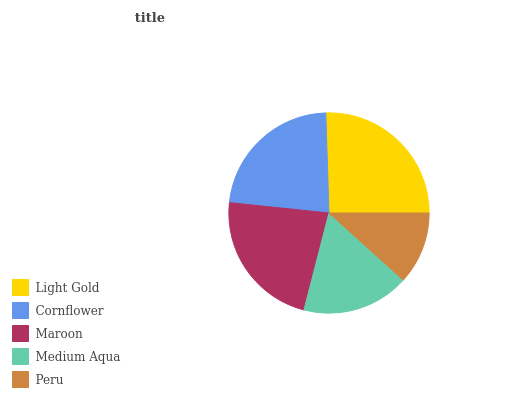Is Peru the minimum?
Answer yes or no. Yes. Is Light Gold the maximum?
Answer yes or no. Yes. Is Cornflower the minimum?
Answer yes or no. No. Is Cornflower the maximum?
Answer yes or no. No. Is Light Gold greater than Cornflower?
Answer yes or no. Yes. Is Cornflower less than Light Gold?
Answer yes or no. Yes. Is Cornflower greater than Light Gold?
Answer yes or no. No. Is Light Gold less than Cornflower?
Answer yes or no. No. Is Maroon the high median?
Answer yes or no. Yes. Is Maroon the low median?
Answer yes or no. Yes. Is Peru the high median?
Answer yes or no. No. Is Peru the low median?
Answer yes or no. No. 